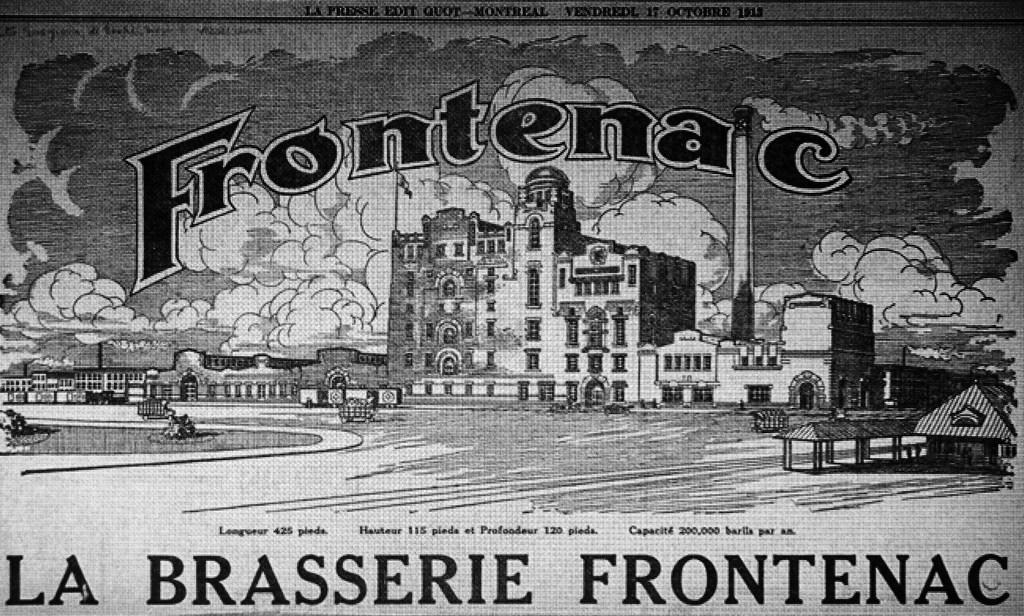What is the color scheme of the image? The image is black and white. What type of structure can be seen in the image? There is a building in the image. What natural elements are visible in the image? There are clouds visible in the image. How many rings are visible on the building in the image? There are no rings present on the building in the image. What type of ice can be seen melting on the building in the image? There is no ice present on the building in the image. 